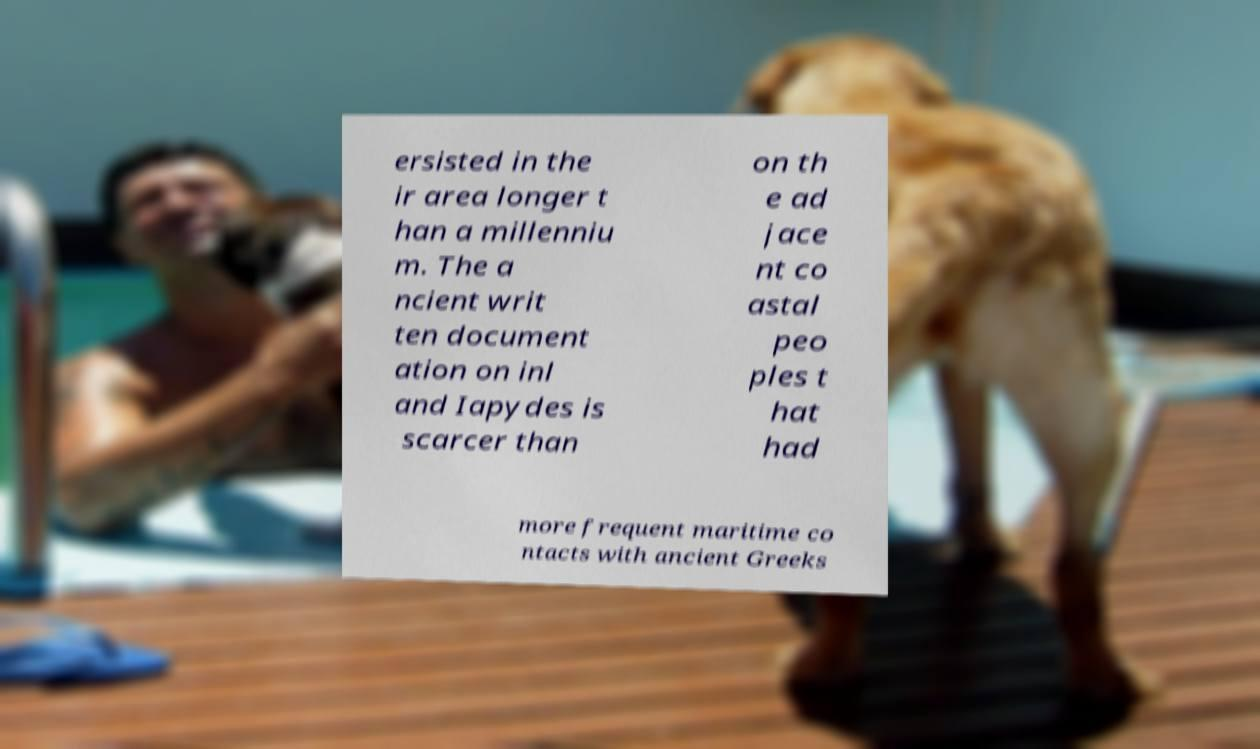There's text embedded in this image that I need extracted. Can you transcribe it verbatim? ersisted in the ir area longer t han a millenniu m. The a ncient writ ten document ation on inl and Iapydes is scarcer than on th e ad jace nt co astal peo ples t hat had more frequent maritime co ntacts with ancient Greeks 